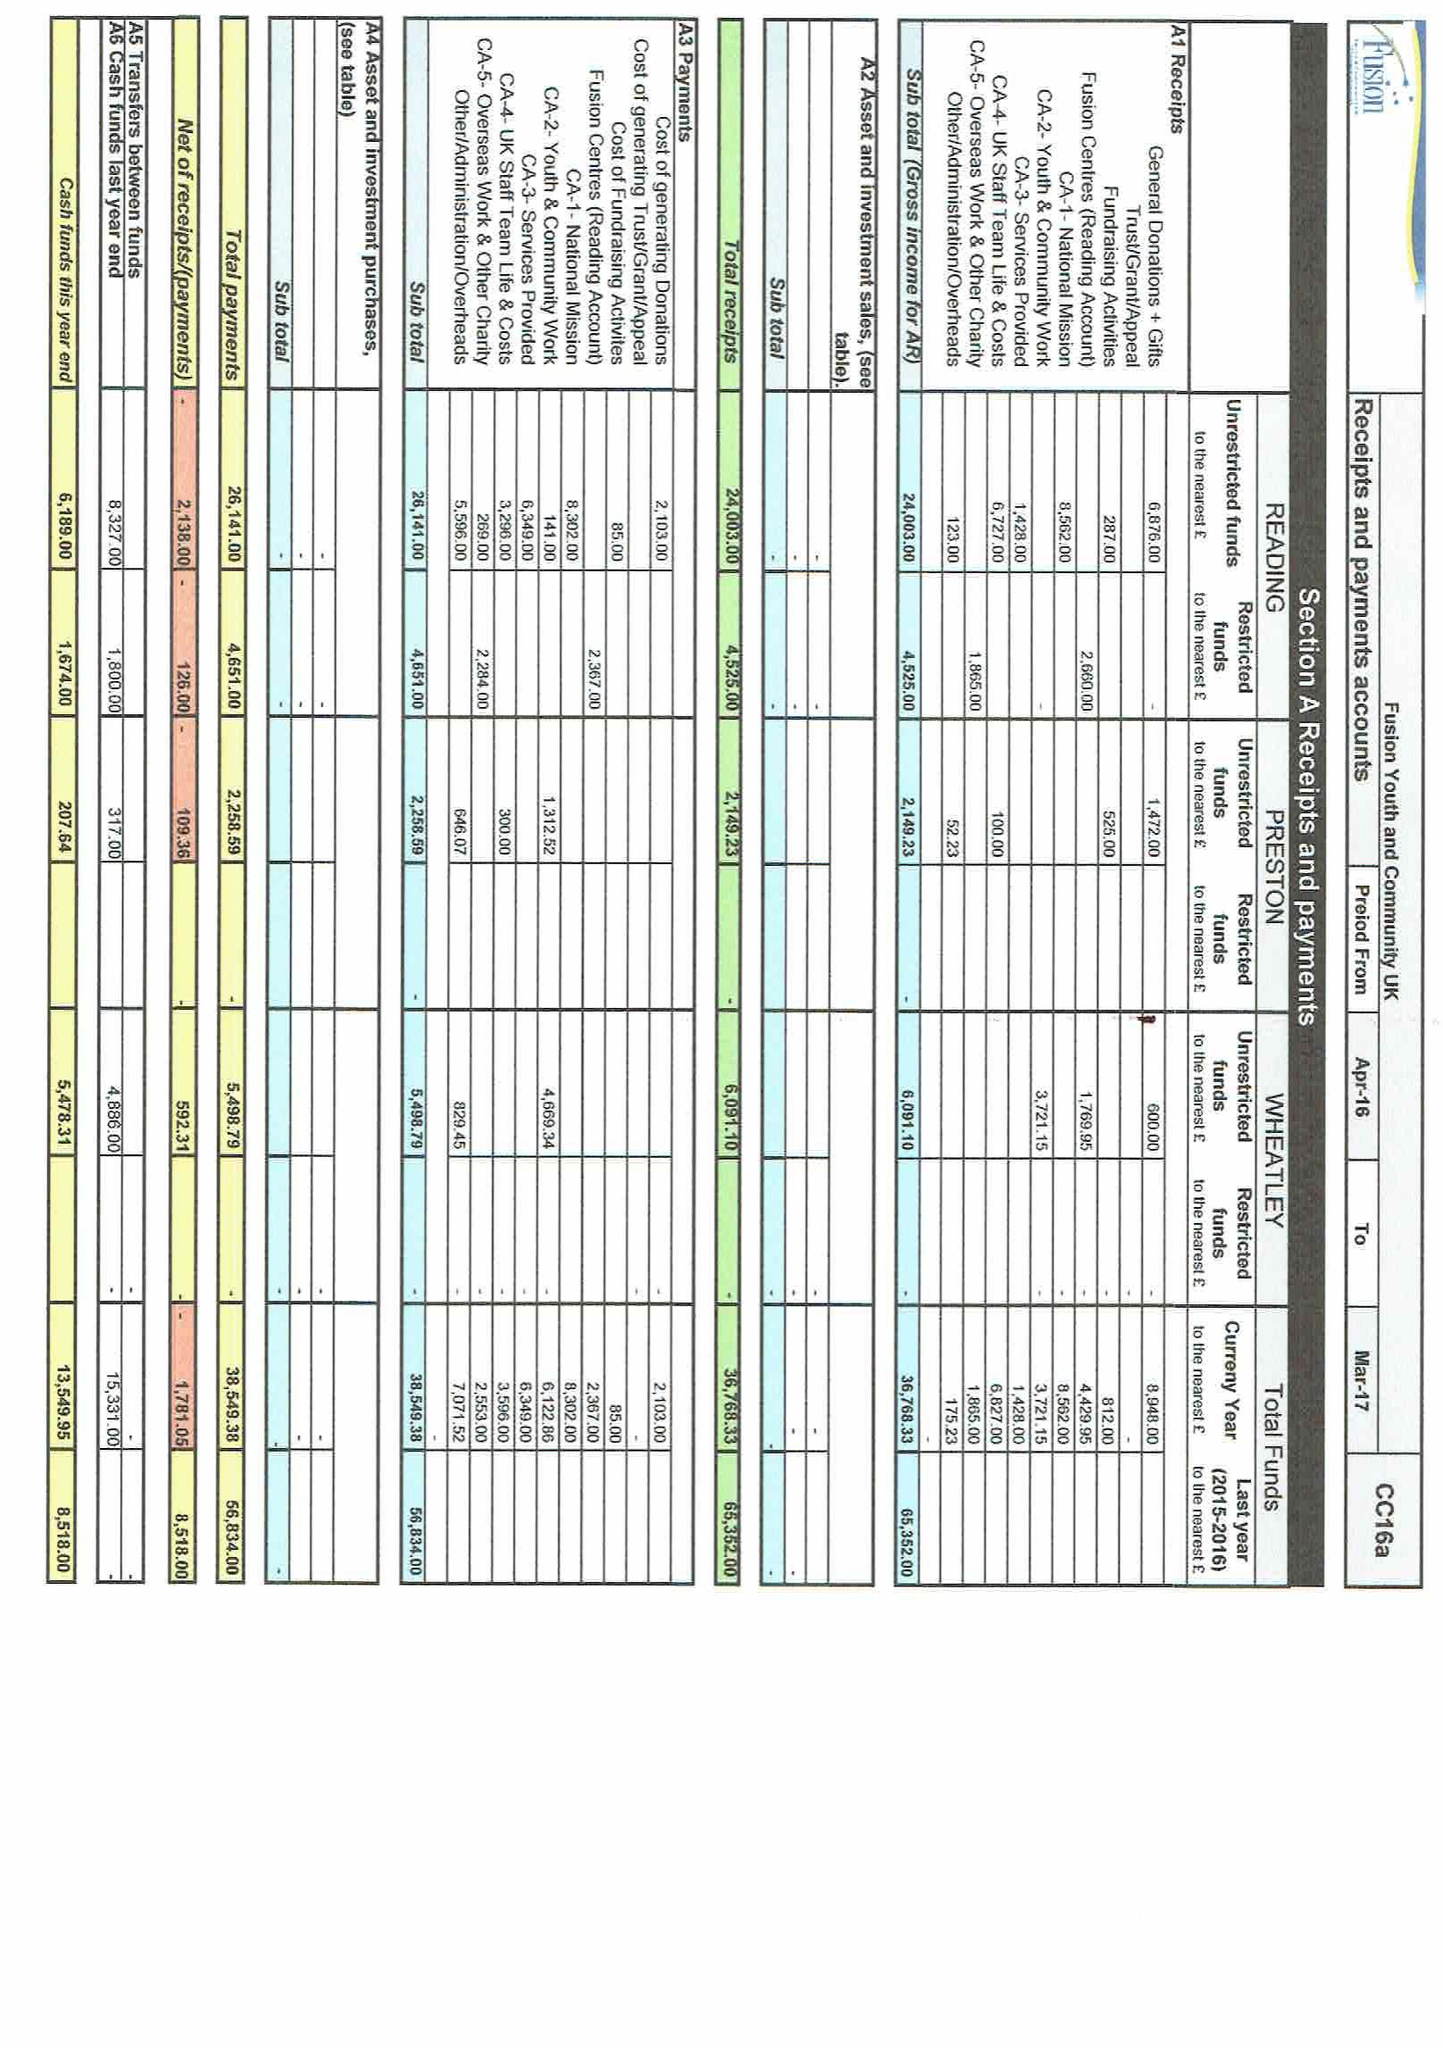What is the value for the address__postcode?
Answer the question using a single word or phrase. RG2 7JE 